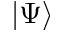Convert formula to latex. <formula><loc_0><loc_0><loc_500><loc_500>| \Psi \rangle</formula> 